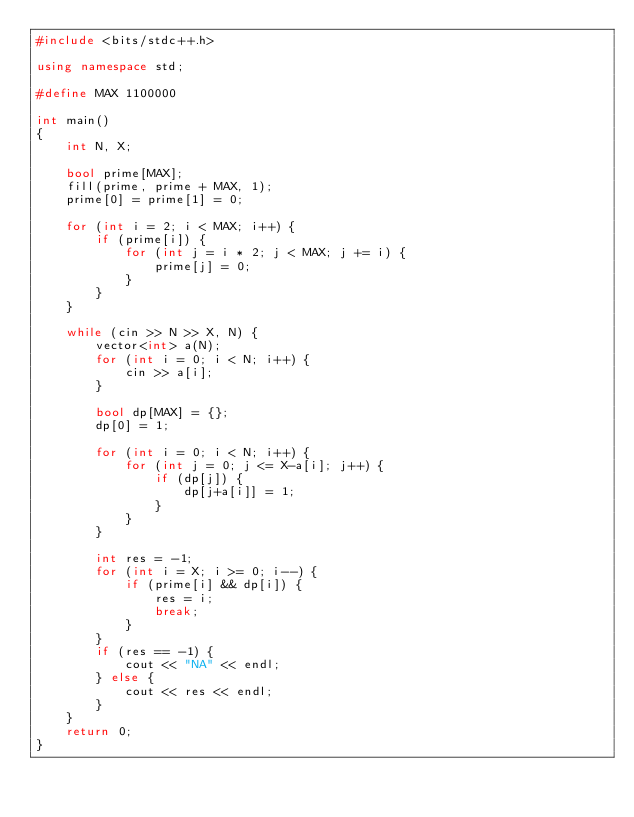<code> <loc_0><loc_0><loc_500><loc_500><_C++_>#include <bits/stdc++.h>

using namespace std;

#define MAX 1100000

int main()
{
    int N, X;
    
    bool prime[MAX];
    fill(prime, prime + MAX, 1);
    prime[0] = prime[1] = 0;

    for (int i = 2; i < MAX; i++) {
        if (prime[i]) {
            for (int j = i * 2; j < MAX; j += i) {
                prime[j] = 0;
            }
        }
    }
    
    while (cin >> N >> X, N) {
        vector<int> a(N);
        for (int i = 0; i < N; i++) {
            cin >> a[i];
        }
        
        bool dp[MAX] = {};
        dp[0] = 1;

        for (int i = 0; i < N; i++) {
            for (int j = 0; j <= X-a[i]; j++) {
                if (dp[j]) {
                    dp[j+a[i]] = 1;
                }
            }
        }
        
        int res = -1;
        for (int i = X; i >= 0; i--) {
            if (prime[i] && dp[i]) {
                res = i;
                break;
            }
        }
        if (res == -1) {
            cout << "NA" << endl;
        } else {
            cout << res << endl;
        }
    }
    return 0;
}</code> 